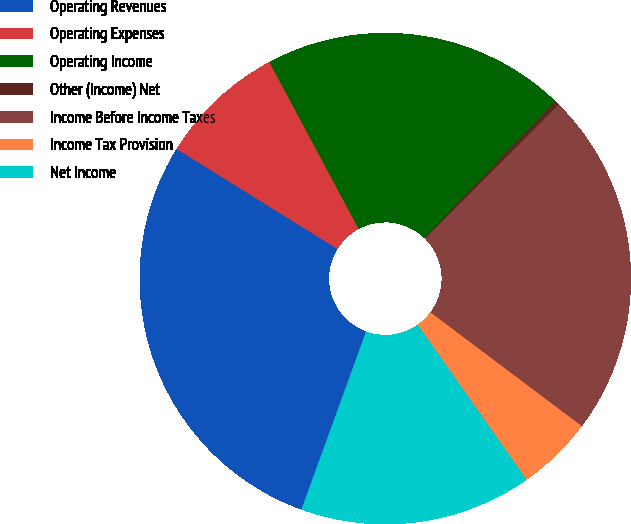Convert chart. <chart><loc_0><loc_0><loc_500><loc_500><pie_chart><fcel>Operating Revenues<fcel>Operating Expenses<fcel>Operating Income<fcel>Other (Income) Net<fcel>Income Before Income Taxes<fcel>Income Tax Provision<fcel>Net Income<nl><fcel>28.31%<fcel>8.33%<fcel>19.99%<fcel>0.3%<fcel>22.79%<fcel>5.0%<fcel>15.29%<nl></chart> 